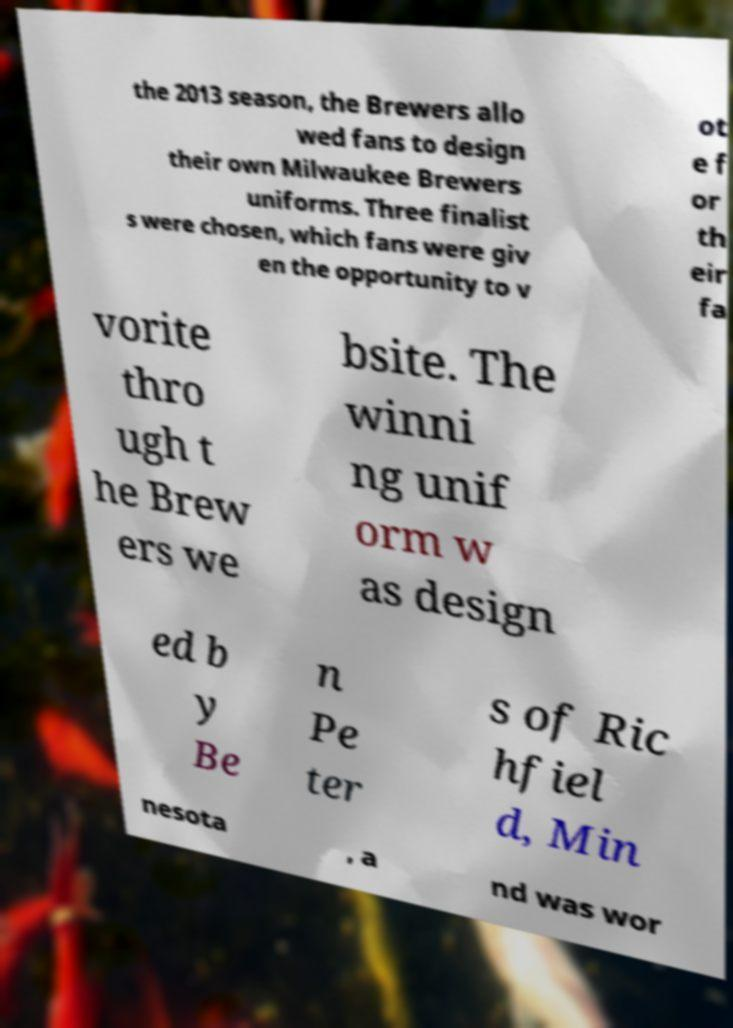For documentation purposes, I need the text within this image transcribed. Could you provide that? the 2013 season, the Brewers allo wed fans to design their own Milwaukee Brewers uniforms. Three finalist s were chosen, which fans were giv en the opportunity to v ot e f or th eir fa vorite thro ugh t he Brew ers we bsite. The winni ng unif orm w as design ed b y Be n Pe ter s of Ric hfiel d, Min nesota , a nd was wor 